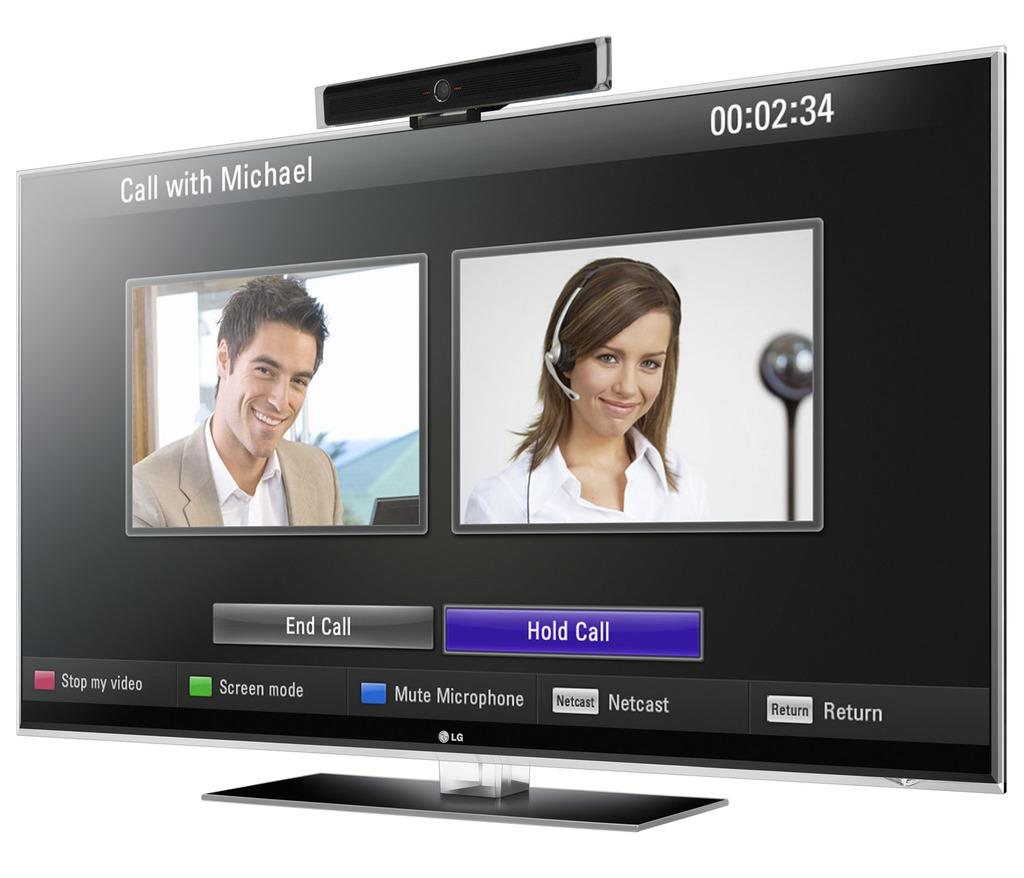<image>
Offer a succinct explanation of the picture presented. Computer screen that says the time is currently 2:34. 